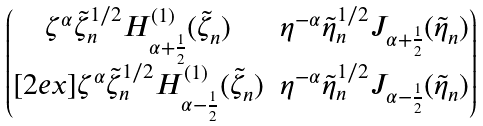Convert formula to latex. <formula><loc_0><loc_0><loc_500><loc_500>\begin{pmatrix} \zeta ^ { \alpha } \tilde { \zeta } _ { n } ^ { 1 / 2 } H _ { \alpha + \frac { 1 } { 2 } } ^ { ( 1 ) } ( \tilde { \zeta } _ { n } ) & \eta ^ { - \alpha } \tilde { \eta } _ { n } ^ { 1 / 2 } J _ { \alpha + \frac { 1 } { 2 } } ( \tilde { \eta } _ { n } ) \\ [ 2 e x ] \zeta ^ { \alpha } \tilde { \zeta } _ { n } ^ { 1 / 2 } H _ { \alpha - \frac { 1 } { 2 } } ^ { ( 1 ) } ( \tilde { \zeta } _ { n } ) & \eta ^ { - \alpha } \tilde { \eta } _ { n } ^ { 1 / 2 } J _ { \alpha - \frac { 1 } { 2 } } ( \tilde { \eta } _ { n } ) \end{pmatrix}</formula> 